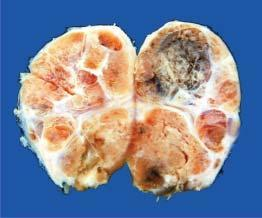re areas of haemorrhage and cystic change also seen?
Answer the question using a single word or phrase. Yes 